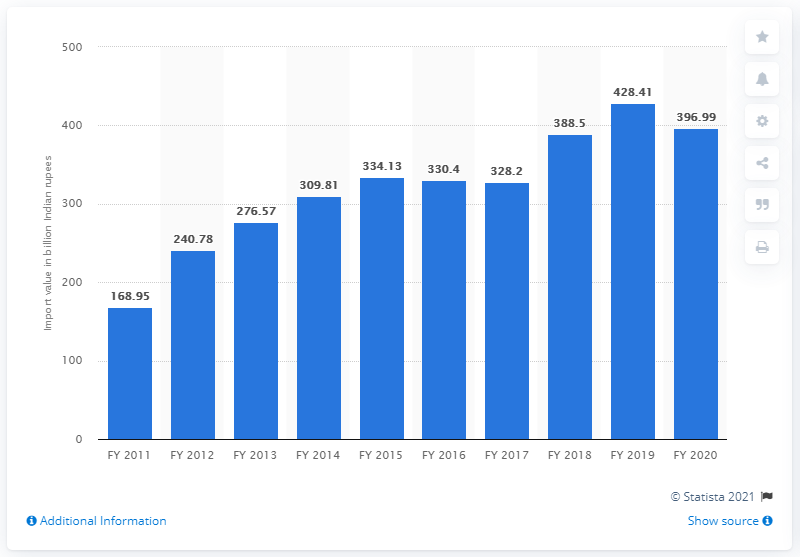Draw attention to some important aspects in this diagram. In Fiscal Year 2019, the value of wood and wood products imported into India was 428.41 billion Indian rupees. The value of imports in India at the end of fiscal year 2020 was 396.99. During the period from FY 2016 to FY 2017, the average value of wood and wood products imported into India was 329.3 million US dollars. 